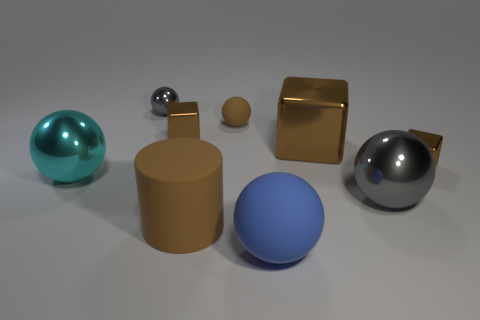Subtract all brown cubes. How many were subtracted if there are1brown cubes left? 2 Subtract all brown spheres. How many spheres are left? 4 Subtract all tiny gray metal spheres. How many spheres are left? 4 Subtract all green balls. Subtract all red cylinders. How many balls are left? 5 Add 1 rubber cubes. How many objects exist? 10 Subtract all cylinders. How many objects are left? 8 Add 2 gray spheres. How many gray spheres exist? 4 Subtract 1 cyan balls. How many objects are left? 8 Subtract all small gray shiny things. Subtract all gray metal objects. How many objects are left? 6 Add 6 large blue balls. How many large blue balls are left? 7 